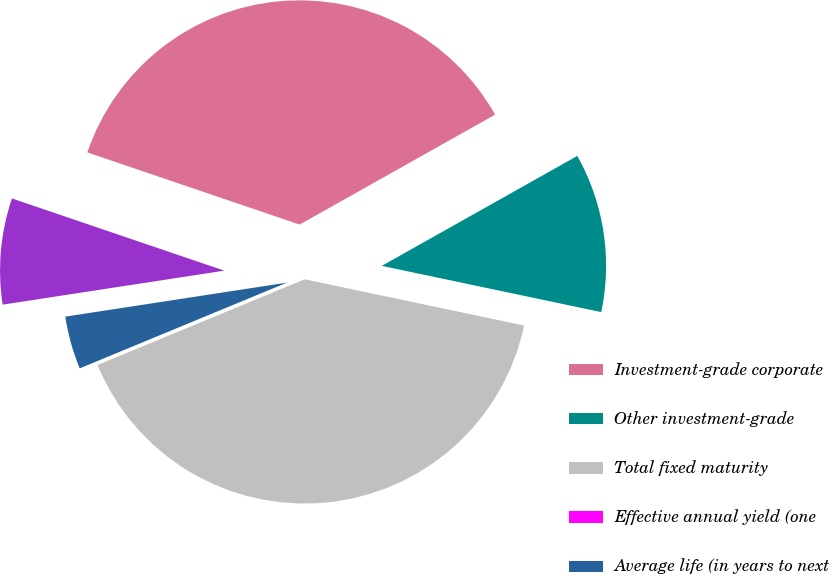<chart> <loc_0><loc_0><loc_500><loc_500><pie_chart><fcel>Investment-grade corporate<fcel>Other investment-grade<fcel>Total fixed maturity<fcel>Effective annual yield (one<fcel>Average life (in years to next<fcel>Average life (in years to<nl><fcel>36.63%<fcel>11.46%<fcel>40.45%<fcel>0.0%<fcel>3.82%<fcel>7.64%<nl></chart> 